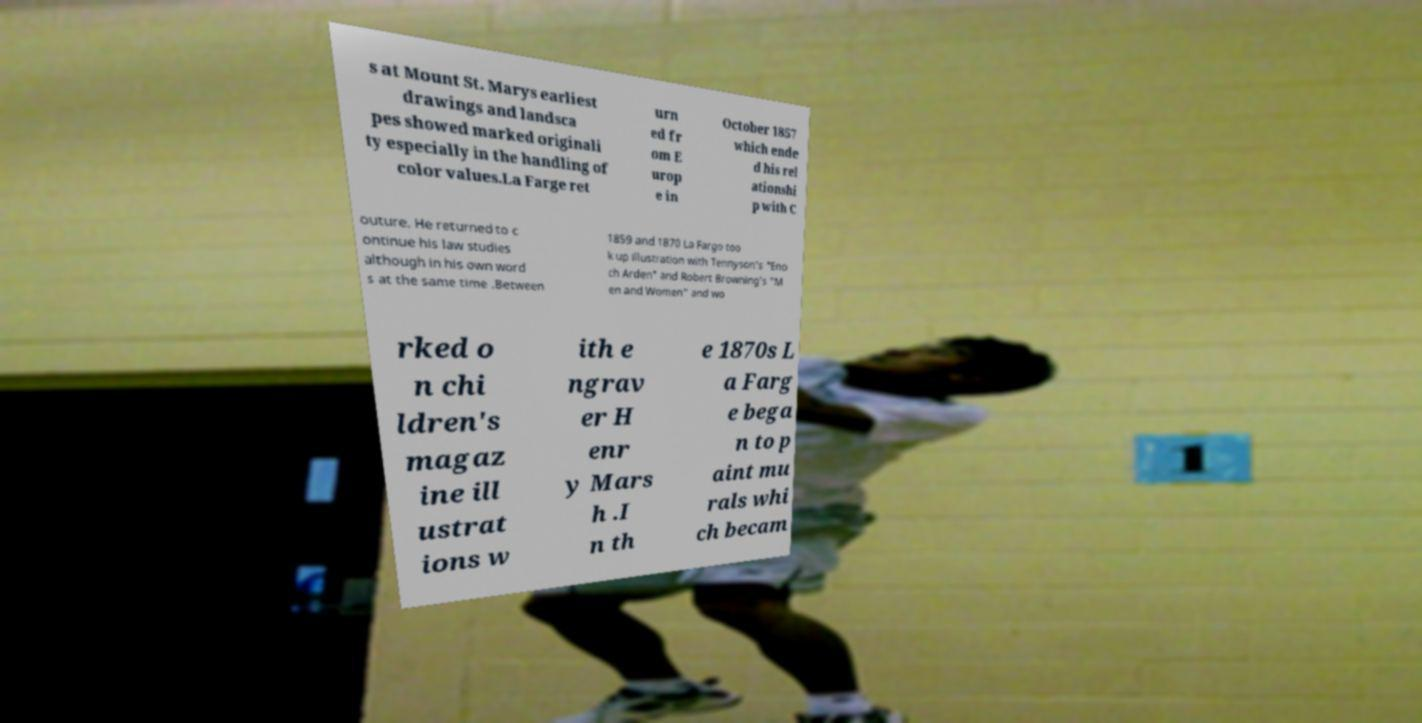Could you assist in decoding the text presented in this image and type it out clearly? s at Mount St. Marys earliest drawings and landsca pes showed marked originali ty especially in the handling of color values.La Farge ret urn ed fr om E urop e in October 1857 which ende d his rel ationshi p with C outure. He returned to c ontinue his law studies although in his own word s at the same time .Between 1859 and 1870 La Fargo too k up illustration with Tennyson's "Eno ch Arden" and Robert Browning's "M en and Women" and wo rked o n chi ldren's magaz ine ill ustrat ions w ith e ngrav er H enr y Mars h .I n th e 1870s L a Farg e bega n to p aint mu rals whi ch becam 